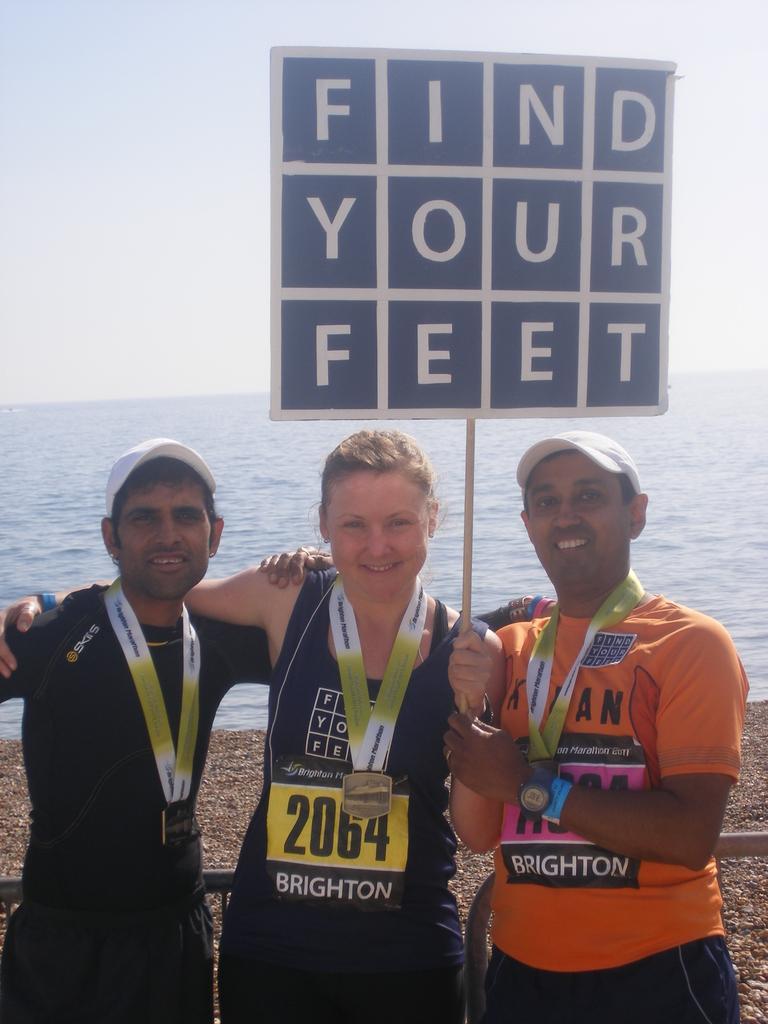In one or two sentences, can you explain what this image depicts? There are three persons standing and wearing medals with tags. Person on the sides are wearing caps. Persons on the right is wearing chest numbers. Middle lady is holding a placard. And the man on the right is wearing a watch. In the background there is water and sky. 